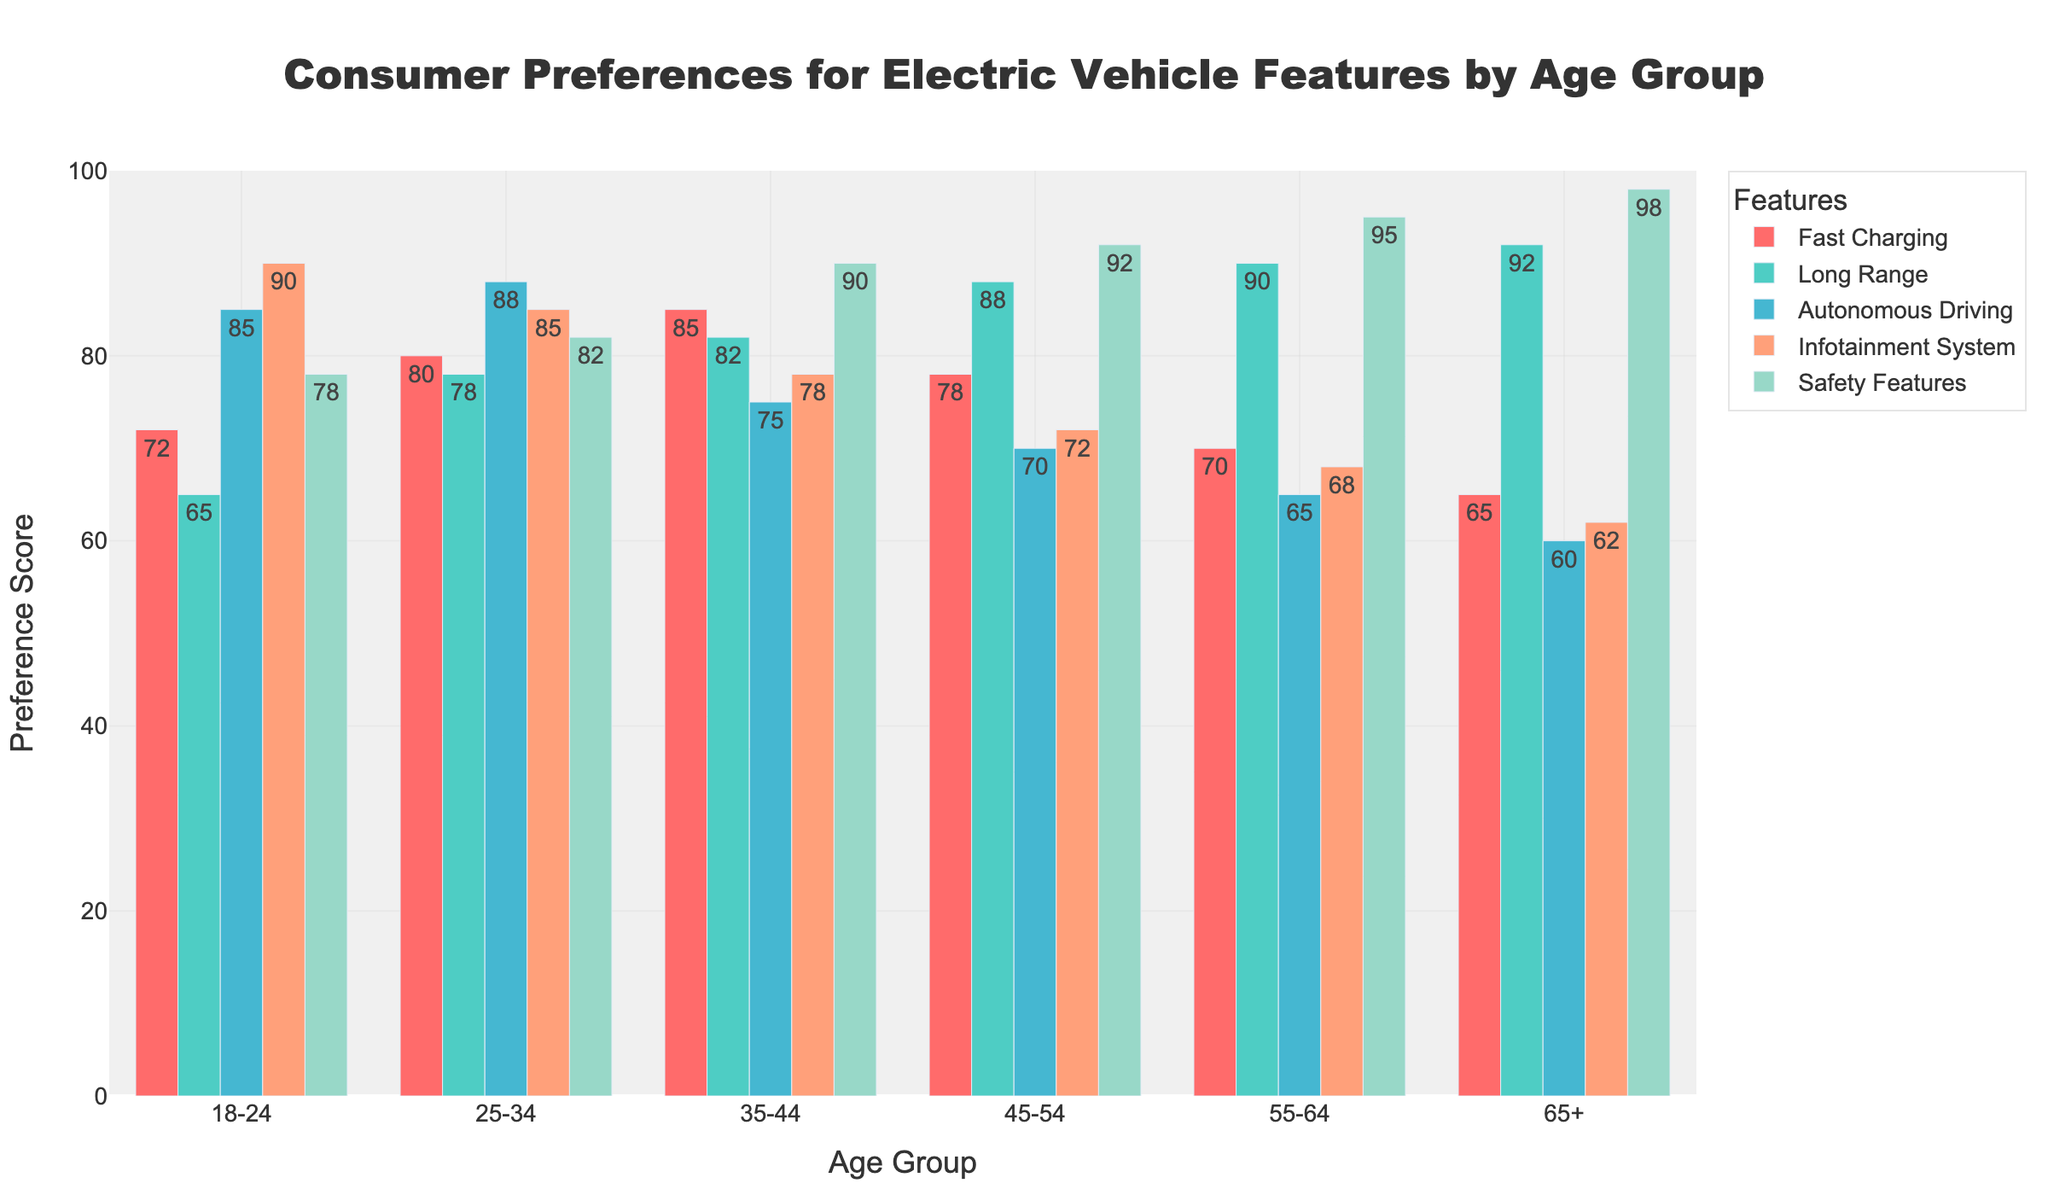What feature is most preferred by the 18-24 age group? By looking at the height of the bars for the 18-24 age group, the tallest bar corresponds to the Infotainment System, indicating it is the most preferred feature.
Answer: Infotainment System Which age group has the highest preference for Fast Charging? Observing the height of the Fast Charging bars across all age groups, the 35-44 group has the tallest bar, indicating the highest preference for this feature.
Answer: 35-44 What is the difference in preference for Safety Features between the 45-54 and 18-24 age groups? The preference scores for Safety Features are 92 for 45-54 and 78 for 18-24. The difference is calculated as 92 - 78.
Answer: 14 Which age group has the lowest preference for Autonomous Driving? By comparing the heights of the Autonomous Driving bars across all age groups, the 65+ group has the shortest bar, indicating the lowest preference.
Answer: 65+ What is the average preference score for the Long Range feature for all age groups? Adding up the Long Range scores (65 + 78 + 82 + 88 + 90 + 92) and dividing by the number of age groups (6) gives the average.
Answer: 82.5 Which feature shows a consistent increase in preference with age? By visually examining the bars for each feature across age groups from left to right, Safety Features show a consistent increase in height.
Answer: Safety Features Compare the preference for Infotainment System between the 18-24 and 65+ age groups. The preference scores for Infotainment System are 90 for 18-24 and 62 for 65+. The preference is higher for the 18-24 group.
Answer: 18-24 What is the sum of preferences for Autonomous Driving and Infotainment System for the 25-34 age group? Adding the preferences for Autonomous Driving (88) and Infotainment System (85) for the 25-34 age group gives the sum.
Answer: 173 Which age group shows the largest difference in preference between Long Range and Fast Charging? Calculating the difference between Long Range and Fast Charging for each age group and comparing them shows 65+ with the largest difference, with values of 92 - 65.
Answer: 65+ What is the median preference score for the Fast Charging feature across all age groups? Sorting the Fast Charging preferences (72, 80, 85, 78, 70, 65) in ascending order and finding the middle value(s) shows two middle values (72, 78), so the median is the average of these two.
Answer: 75 